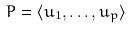<formula> <loc_0><loc_0><loc_500><loc_500>P = \langle u _ { 1 } , \dots , u _ { p } \rangle</formula> 